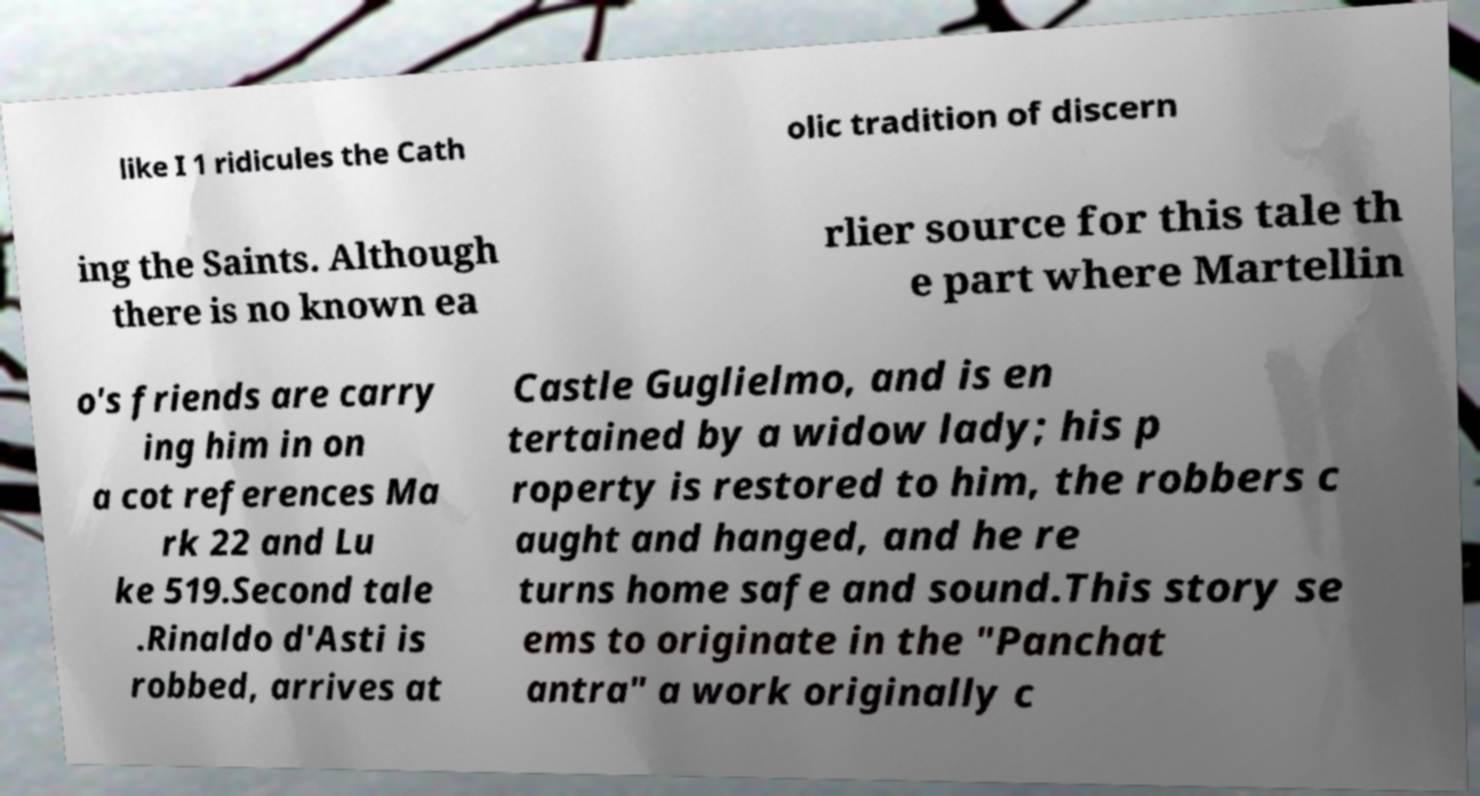Please identify and transcribe the text found in this image. like I 1 ridicules the Cath olic tradition of discern ing the Saints. Although there is no known ea rlier source for this tale th e part where Martellin o's friends are carry ing him in on a cot references Ma rk 22 and Lu ke 519.Second tale .Rinaldo d'Asti is robbed, arrives at Castle Guglielmo, and is en tertained by a widow lady; his p roperty is restored to him, the robbers c aught and hanged, and he re turns home safe and sound.This story se ems to originate in the "Panchat antra" a work originally c 